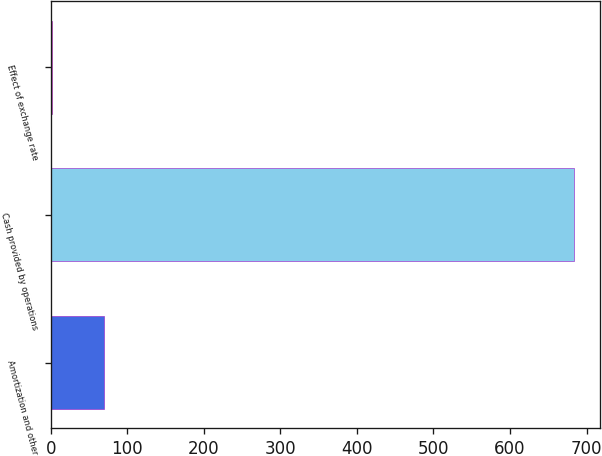<chart> <loc_0><loc_0><loc_500><loc_500><bar_chart><fcel>Amortization and other<fcel>Cash provided by operations<fcel>Effect of exchange rate<nl><fcel>70.1<fcel>683<fcel>2<nl></chart> 